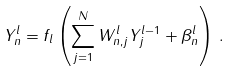<formula> <loc_0><loc_0><loc_500><loc_500>Y ^ { l } _ { n } = f _ { l } \left ( \sum _ { j = 1 } ^ { N } W ^ { l } _ { n , j } Y ^ { l - 1 } _ { j } + \beta ^ { l } _ { n } \right ) \, .</formula> 